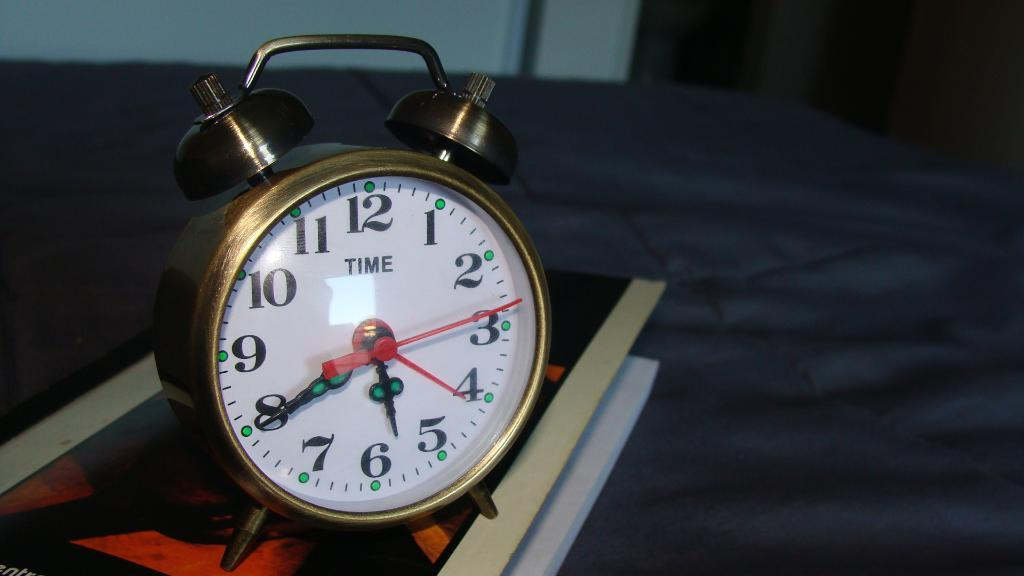<image>
Provide a brief description of the given image. An old fashioned alarm clock displaying the time of 5:40. 